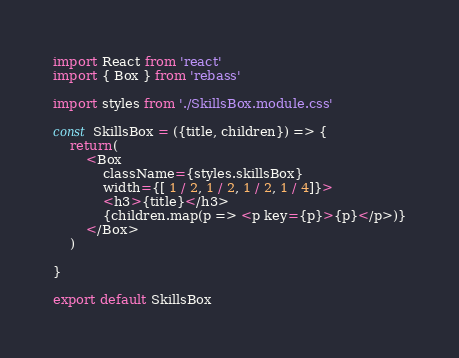Convert code to text. <code><loc_0><loc_0><loc_500><loc_500><_JavaScript_>import React from 'react'
import { Box } from 'rebass'

import styles from './SkillsBox.module.css'

const SkillsBox = ({title, children}) => {
    return(
        <Box
            className={styles.skillsBox}
            width={[ 1 / 2, 1 / 2, 1 / 2, 1 / 4]}>
            <h3>{title}</h3>
            {children.map(p => <p key={p}>{p}</p>)}
        </Box>
    )
    
}

export default SkillsBox</code> 